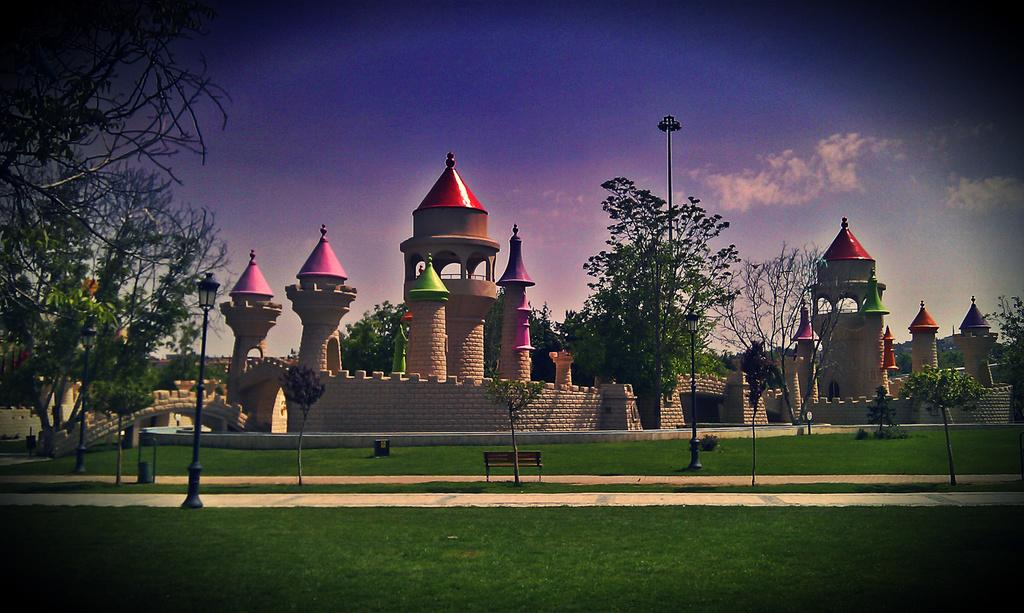What type of structure can be seen in the picture? There is a fort in the picture. What type of barrier surrounds the fort? There is a fence wall in the picture. What type of vegetation is visible in the picture? Grass, plants, and trees are visible in the picture. What type of lighting is present in the picture? Pole lights are in the picture. What type of seating is available in the picture? There is a bench in the picture. What else can be seen in the picture besides the mentioned objects? There are other objects in the picture. What can be seen in the background of the picture? The sky is visible in the background of the picture. What type of bead is used to decorate the garden in the picture? There is no garden present in the picture, and therefore no beads for decoration. What type of park is visible in the picture? There is no park present in the picture; it features a fort and surrounding elements. 